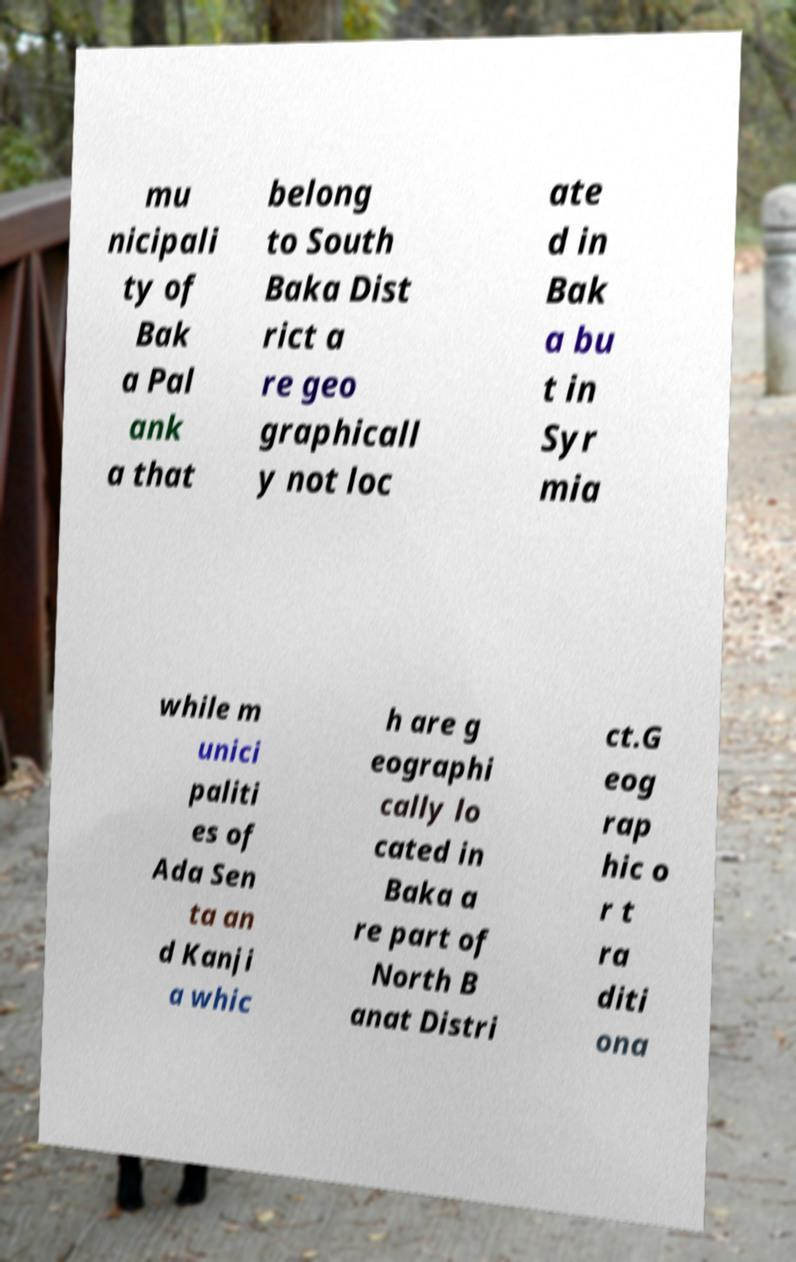What messages or text are displayed in this image? I need them in a readable, typed format. mu nicipali ty of Bak a Pal ank a that belong to South Baka Dist rict a re geo graphicall y not loc ate d in Bak a bu t in Syr mia while m unici paliti es of Ada Sen ta an d Kanji a whic h are g eographi cally lo cated in Baka a re part of North B anat Distri ct.G eog rap hic o r t ra diti ona 